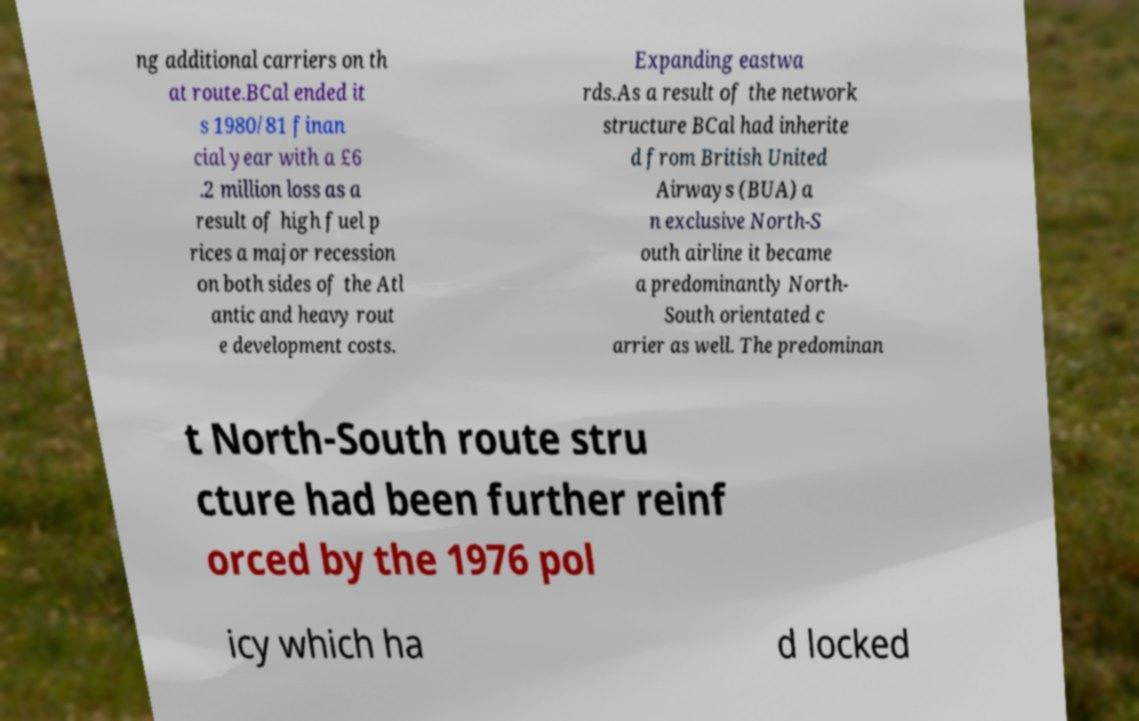I need the written content from this picture converted into text. Can you do that? ng additional carriers on th at route.BCal ended it s 1980/81 finan cial year with a £6 .2 million loss as a result of high fuel p rices a major recession on both sides of the Atl antic and heavy rout e development costs. Expanding eastwa rds.As a result of the network structure BCal had inherite d from British United Airways (BUA) a n exclusive North-S outh airline it became a predominantly North- South orientated c arrier as well. The predominan t North-South route stru cture had been further reinf orced by the 1976 pol icy which ha d locked 